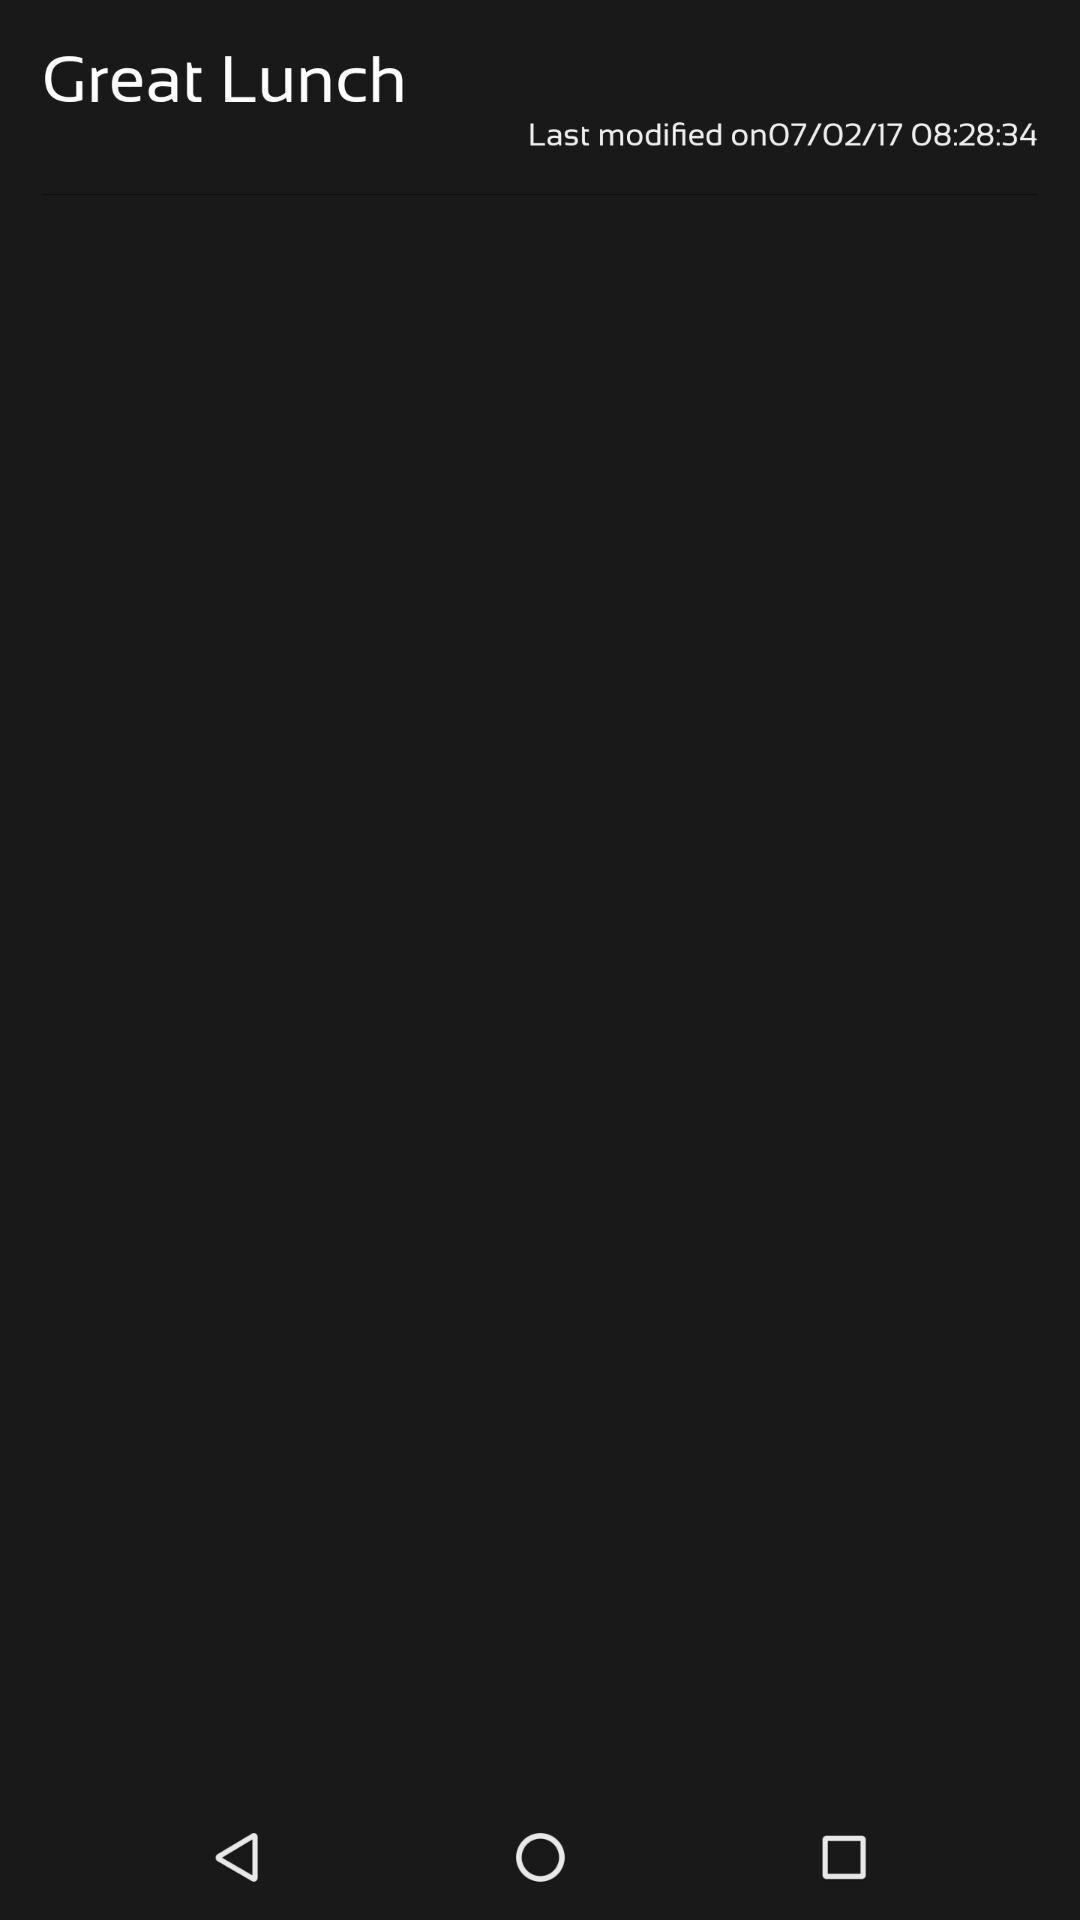What is the overall content of this screenshot? Screen shows about a great lunch. 